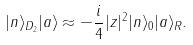Convert formula to latex. <formula><loc_0><loc_0><loc_500><loc_500>| n \rangle _ { D _ { 2 } } | a \rangle \approx - \frac { i } { 4 } | z | ^ { 2 } | n \rangle _ { 0 } | a \rangle _ { R } .</formula> 